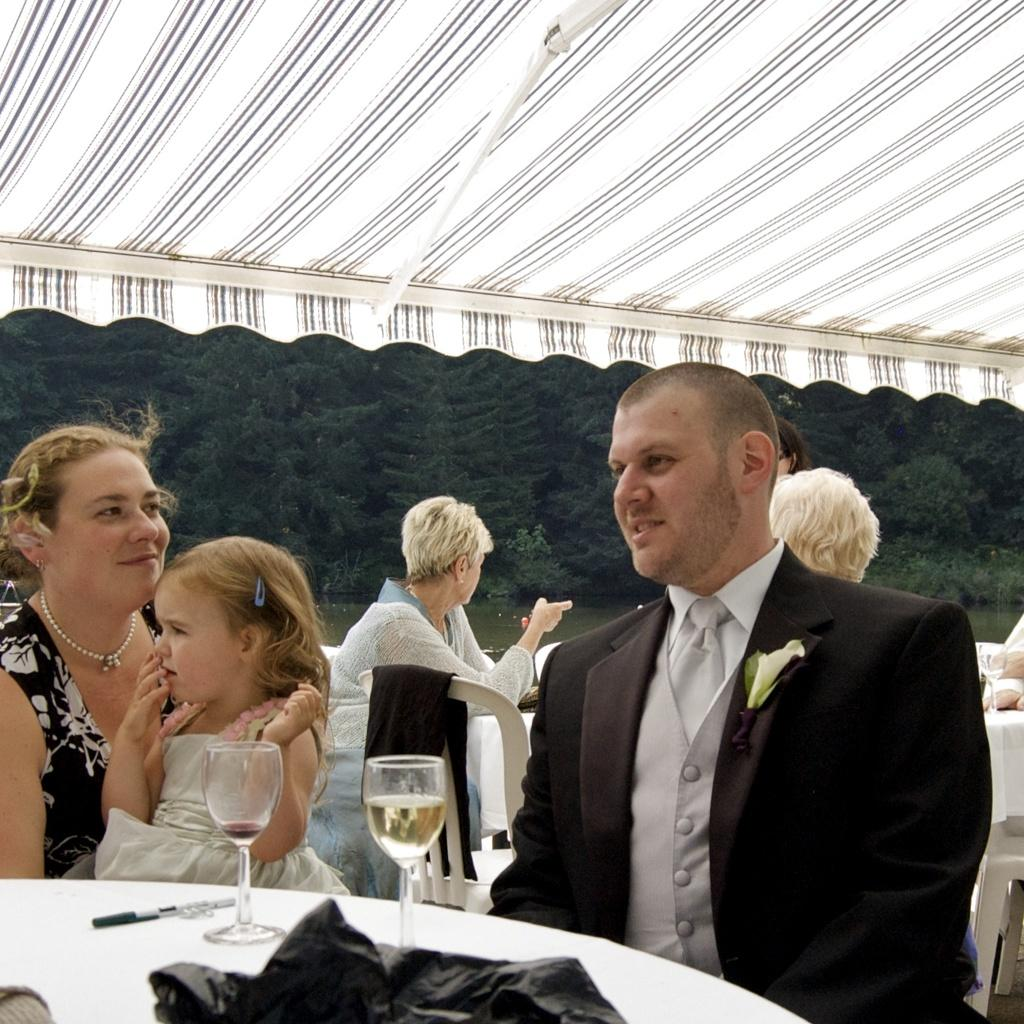What are the people in the image doing? The people in the image are sitting on chairs. What is on the table in the image? There are glasses, a pen, and other items on the table. Can you describe the background of the image? There is water and trees visible in the background of the image. What type of wax is being used by the team in the image? There is no team or wax present in the image. 